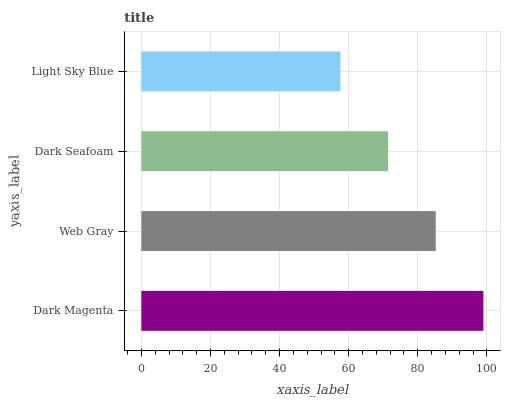Is Light Sky Blue the minimum?
Answer yes or no. Yes. Is Dark Magenta the maximum?
Answer yes or no. Yes. Is Web Gray the minimum?
Answer yes or no. No. Is Web Gray the maximum?
Answer yes or no. No. Is Dark Magenta greater than Web Gray?
Answer yes or no. Yes. Is Web Gray less than Dark Magenta?
Answer yes or no. Yes. Is Web Gray greater than Dark Magenta?
Answer yes or no. No. Is Dark Magenta less than Web Gray?
Answer yes or no. No. Is Web Gray the high median?
Answer yes or no. Yes. Is Dark Seafoam the low median?
Answer yes or no. Yes. Is Dark Seafoam the high median?
Answer yes or no. No. Is Web Gray the low median?
Answer yes or no. No. 